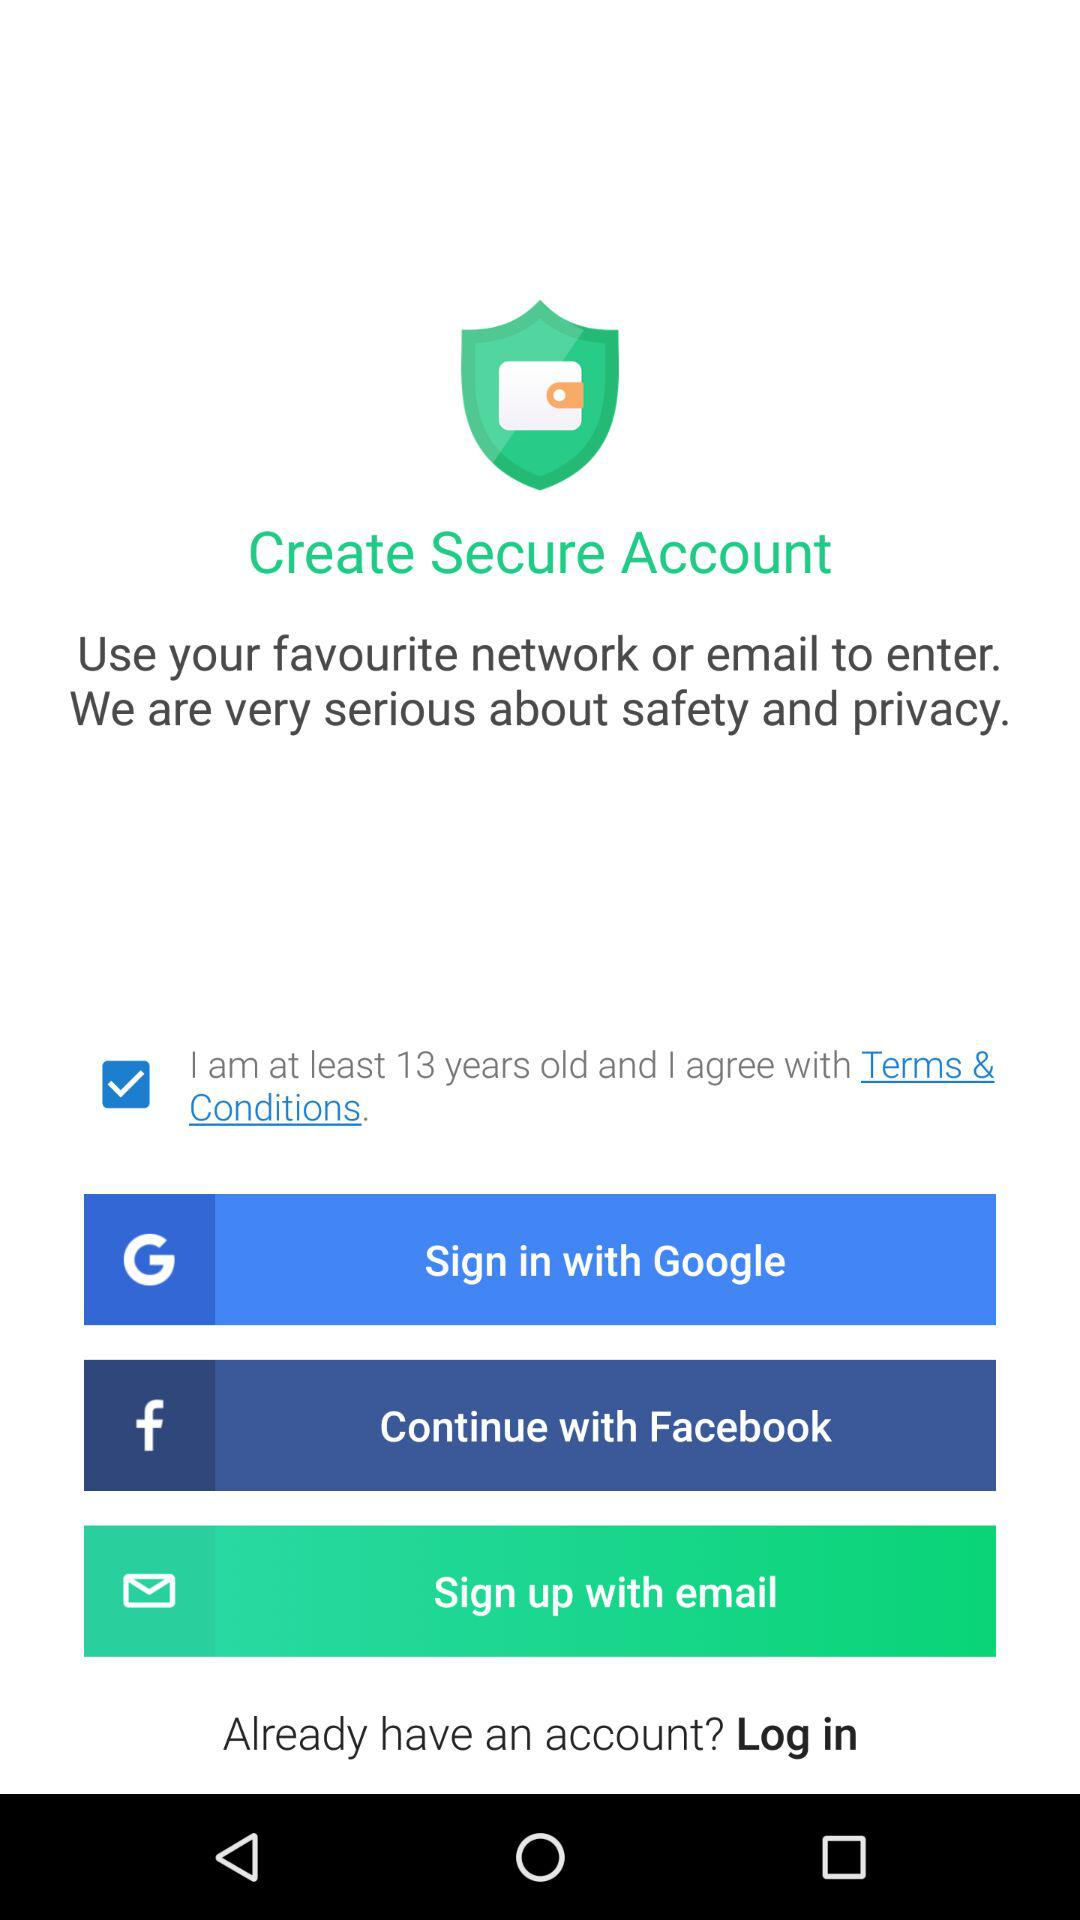Which social sites can we use to log in? You can use "Facebook" to log in. 